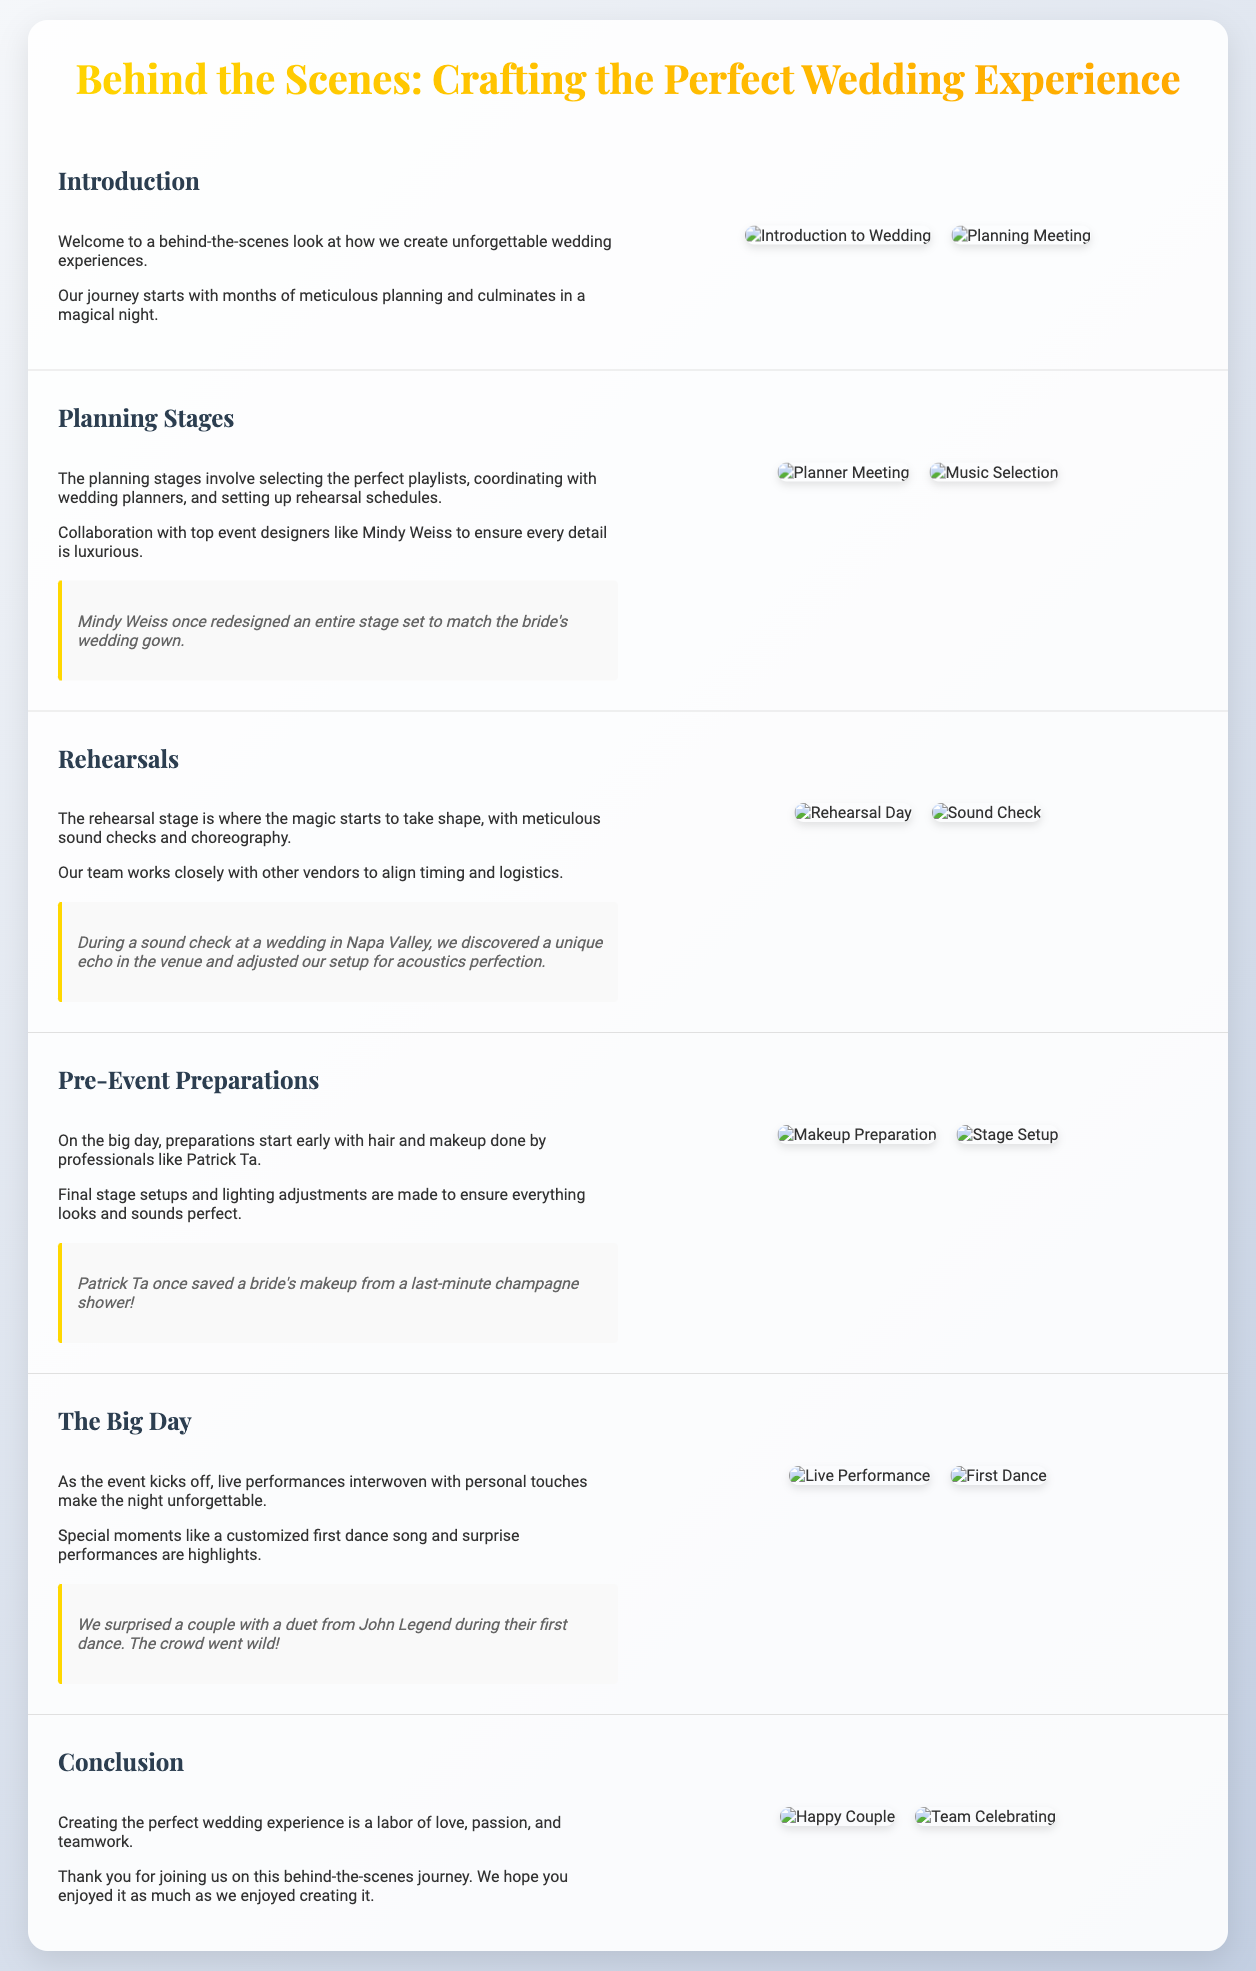What is the title of the presentation? The title of the presentation is the main heading found at the top of the document, which introduces the theme of the slides.
Answer: Behind the Scenes: Crafting the Perfect Wedding Experience Who redesigned an entire stage set? This question refers to a specific anecdote about a wedding planner mentioned in the second slide, highlighting their impressive work during the planning stages.
Answer: Mindy Weiss What type of professionals handle hair and makeup? The description of the pre-event preparations indicates the type of experts responsible for beauty services on the wedding day.
Answer: Professionals What significant moment occurred during the first dance? This question pertains to a special event mentioned in the concluding slide, showcasing a memorable experience for the couple.
Answer: Duet from John Legend Which city was mentioned during a sound check? This refers to a specific location highlighted in the rehearsals slide, indicating where a noteworthy event took place.
Answer: Napa Valley How many images are displayed in the "Planning Stages" slide? This question focuses on the visual content of the slide, specifically counting the images presented in that section.
Answer: 2 